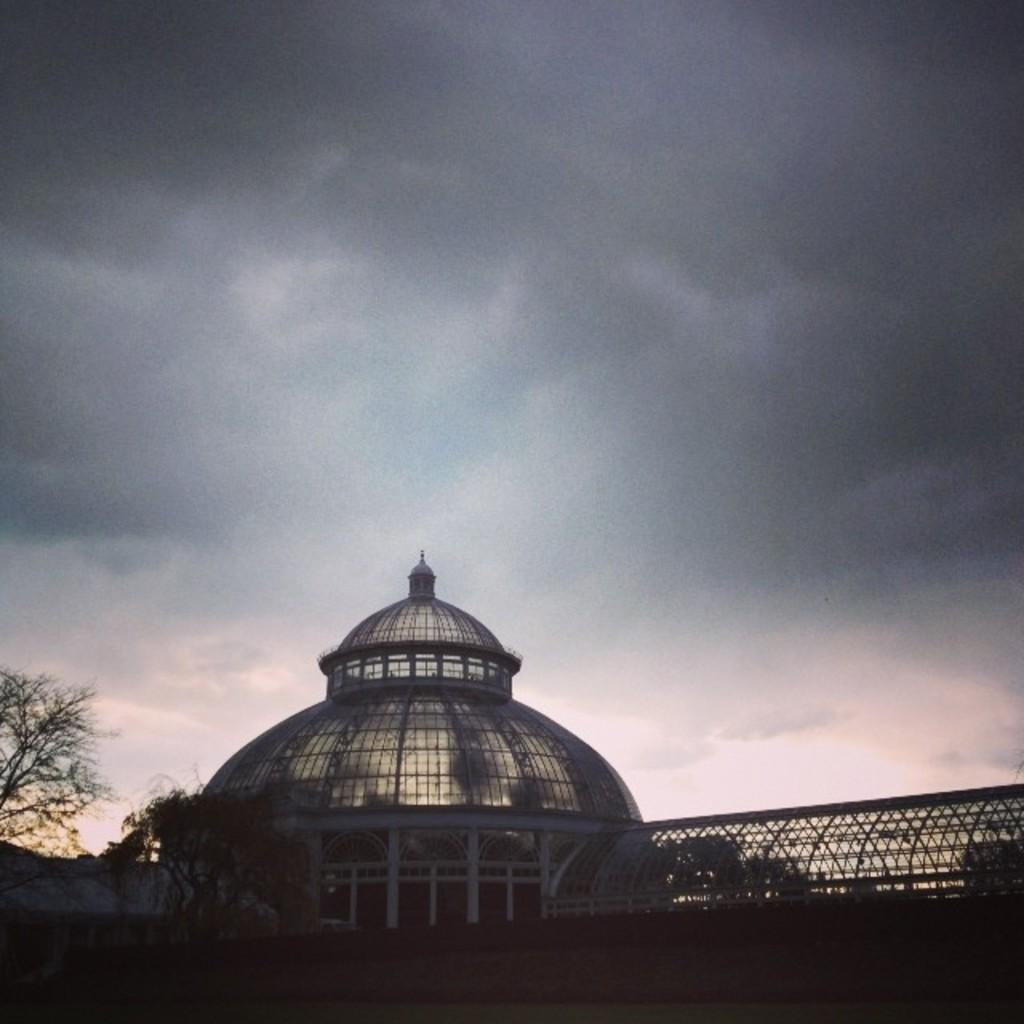What type of structure is present in the image? There is a building with pillars in the image. What other natural elements can be seen in the image? There are trees in the image. What can be seen in the background of the image? The sky is visible in the background of the image. Where is the chicken wearing a sweater in the image? There is no chicken wearing a sweater present in the image. 